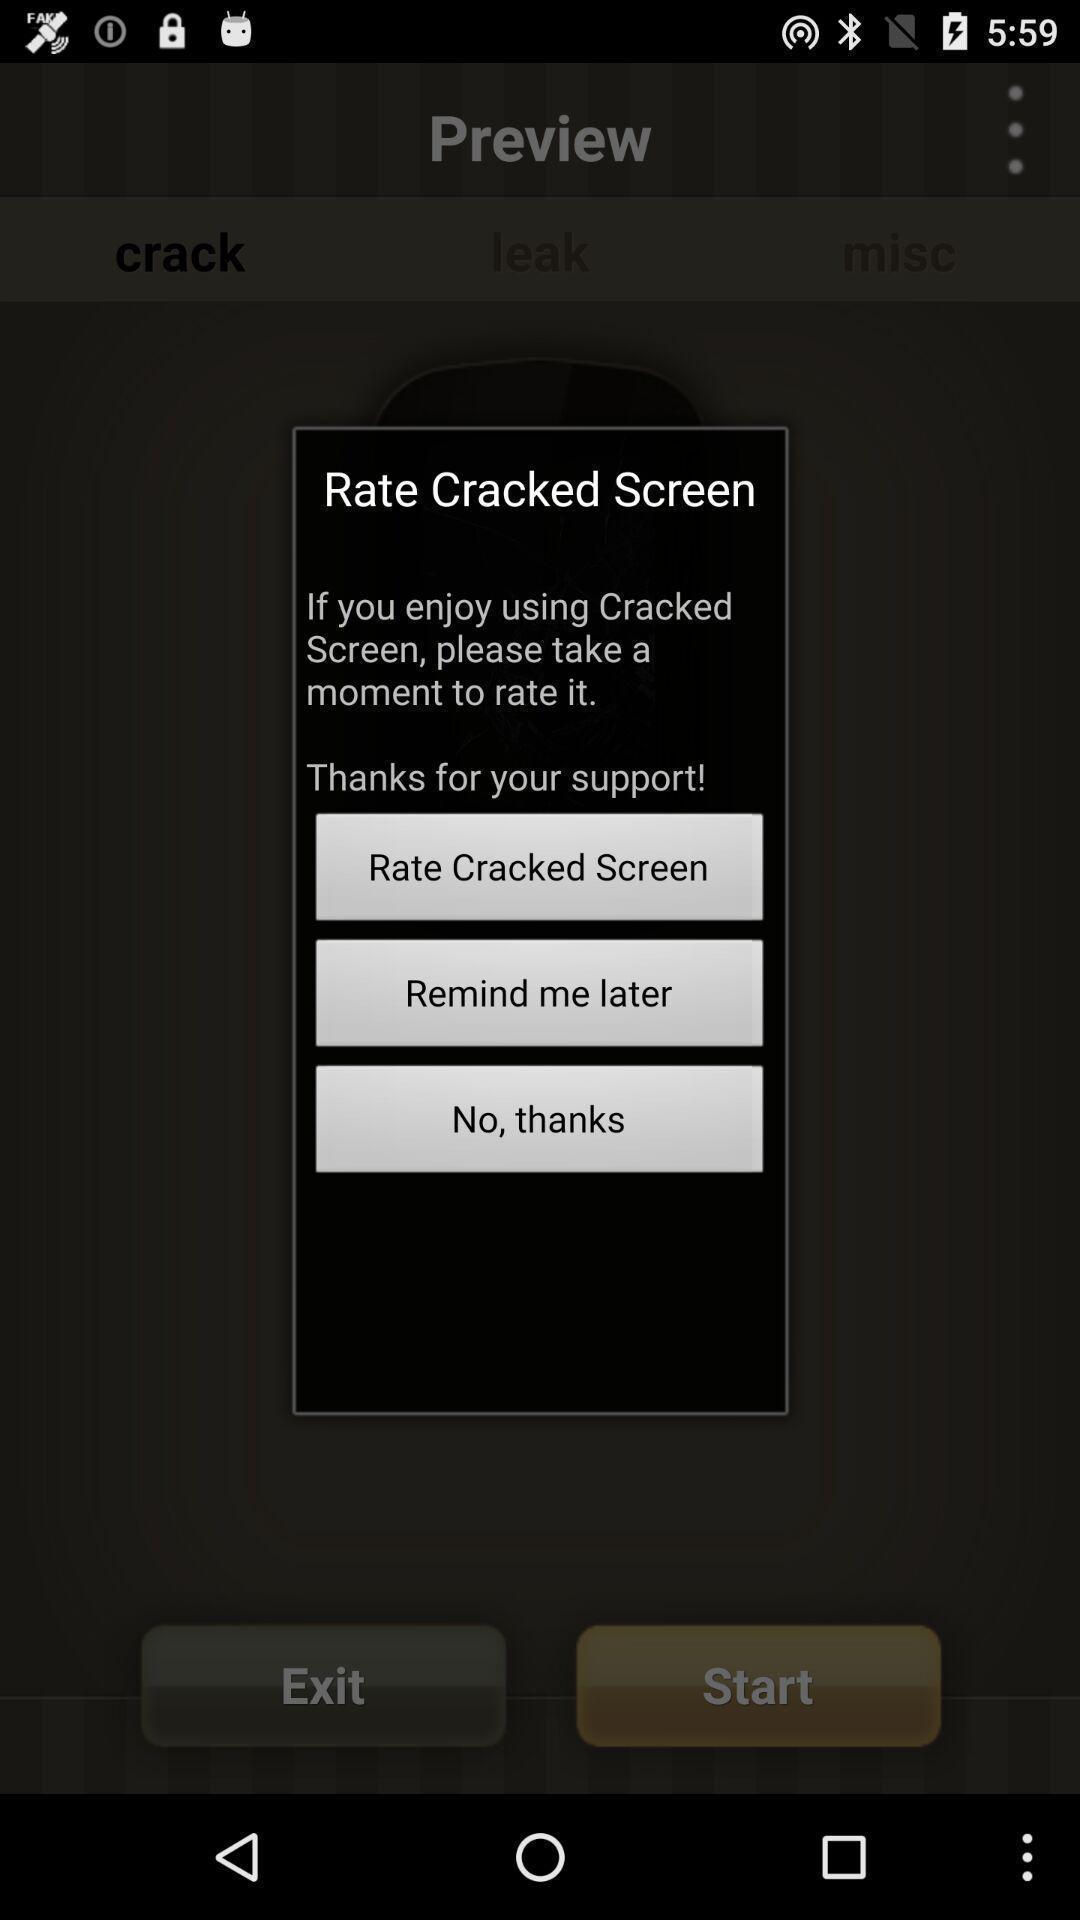Please provide a description for this image. Popup showing few options and text. 